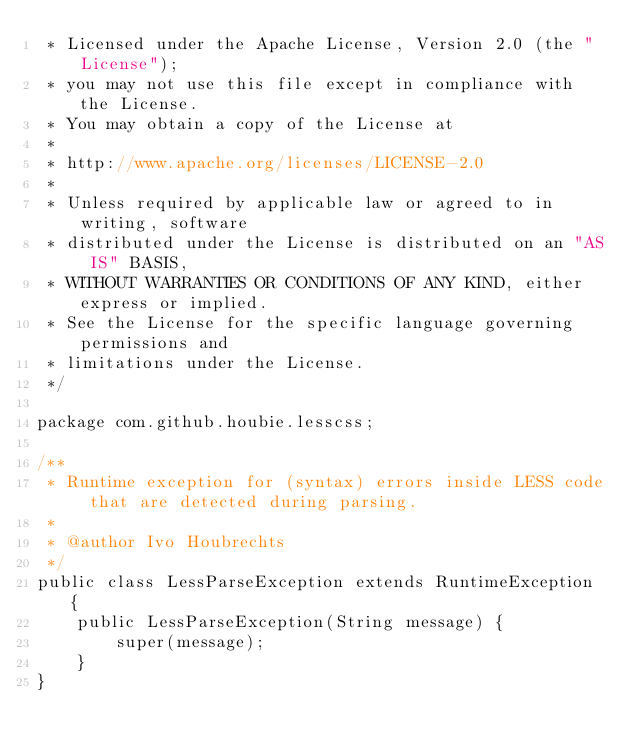Convert code to text. <code><loc_0><loc_0><loc_500><loc_500><_Java_> * Licensed under the Apache License, Version 2.0 (the "License");
 * you may not use this file except in compliance with the License.
 * You may obtain a copy of the License at
 *
 * http://www.apache.org/licenses/LICENSE-2.0
 *
 * Unless required by applicable law or agreed to in writing, software
 * distributed under the License is distributed on an "AS IS" BASIS,
 * WITHOUT WARRANTIES OR CONDITIONS OF ANY KIND, either express or implied.
 * See the License for the specific language governing permissions and
 * limitations under the License.
 */

package com.github.houbie.lesscss;

/**
 * Runtime exception for (syntax) errors inside LESS code that are detected during parsing.
 *
 * @author Ivo Houbrechts
 */
public class LessParseException extends RuntimeException {
    public LessParseException(String message) {
        super(message);
    }
}
</code> 